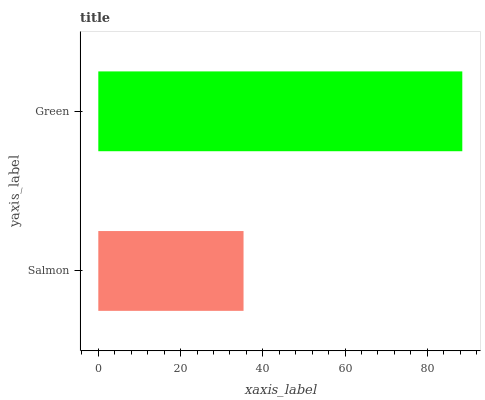Is Salmon the minimum?
Answer yes or no. Yes. Is Green the maximum?
Answer yes or no. Yes. Is Green the minimum?
Answer yes or no. No. Is Green greater than Salmon?
Answer yes or no. Yes. Is Salmon less than Green?
Answer yes or no. Yes. Is Salmon greater than Green?
Answer yes or no. No. Is Green less than Salmon?
Answer yes or no. No. Is Green the high median?
Answer yes or no. Yes. Is Salmon the low median?
Answer yes or no. Yes. Is Salmon the high median?
Answer yes or no. No. Is Green the low median?
Answer yes or no. No. 